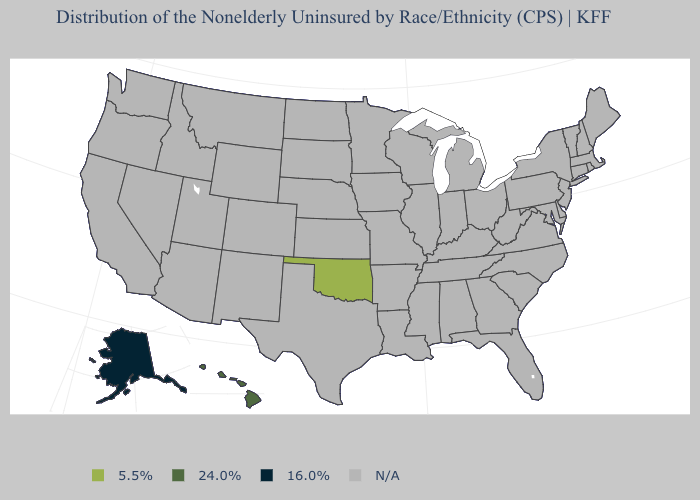Name the states that have a value in the range 16.0%?
Concise answer only. Alaska. Name the states that have a value in the range N/A?
Concise answer only. Alabama, Arizona, Arkansas, California, Colorado, Connecticut, Delaware, Florida, Georgia, Idaho, Illinois, Indiana, Iowa, Kansas, Kentucky, Louisiana, Maine, Maryland, Massachusetts, Michigan, Minnesota, Mississippi, Missouri, Montana, Nebraska, Nevada, New Hampshire, New Jersey, New Mexico, New York, North Carolina, North Dakota, Ohio, Oregon, Pennsylvania, Rhode Island, South Carolina, South Dakota, Tennessee, Texas, Utah, Vermont, Virginia, Washington, West Virginia, Wisconsin, Wyoming. Name the states that have a value in the range 5.5%?
Concise answer only. Oklahoma. Does the first symbol in the legend represent the smallest category?
Quick response, please. No. How many symbols are there in the legend?
Answer briefly. 4. What is the value of Wyoming?
Keep it brief. N/A. Does the first symbol in the legend represent the smallest category?
Short answer required. No. Name the states that have a value in the range 5.5%?
Give a very brief answer. Oklahoma. What is the value of Maryland?
Short answer required. N/A. Name the states that have a value in the range 16.0%?
Keep it brief. Alaska. 